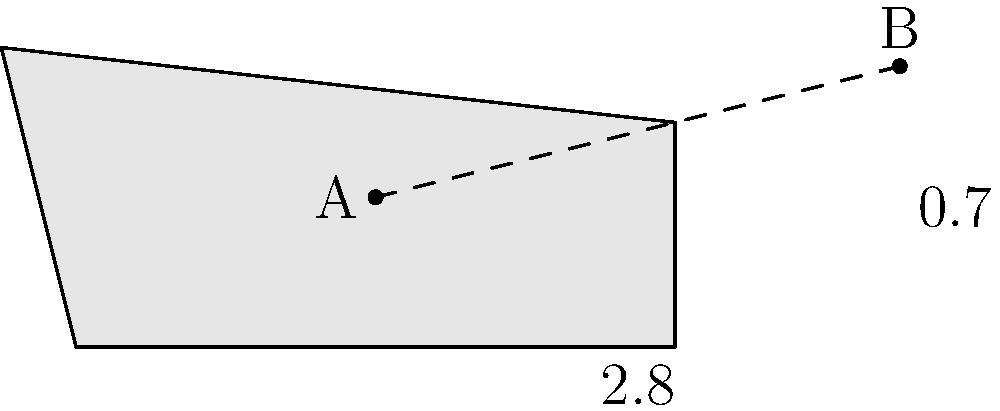On a Converse shoe sole, point A is located at the heel, and point B is near the toe. Given that the horizontal distance between A and B is 2.8 units, and the vertical distance is 0.7 units, calculate the straight-line distance between these two points on the shoe sole. To find the straight-line distance between two points, we can use the distance formula, which is derived from the Pythagorean theorem:

$$d = \sqrt{(x_2 - x_1)^2 + (y_2 - y_1)^2}$$

Where $(x_1, y_1)$ are the coordinates of point A and $(x_2, y_2)$ are the coordinates of point B.

Let's solve this step-by-step:

1) We're given the horizontal distance (change in x) is 2.8 units and the vertical distance (change in y) is 0.7 units.

2) Plugging these values into the distance formula:

   $$d = \sqrt{(2.8)^2 + (0.7)^2}$$

3) Simplify inside the parentheses:

   $$d = \sqrt{7.84 + 0.49}$$

4) Add under the square root:

   $$d = \sqrt{8.33}$$

5) Simplify the square root:

   $$d \approx 2.89$$

Therefore, the straight-line distance between points A and B on the Converse shoe sole is approximately 2.89 units.
Answer: $2.89$ units 